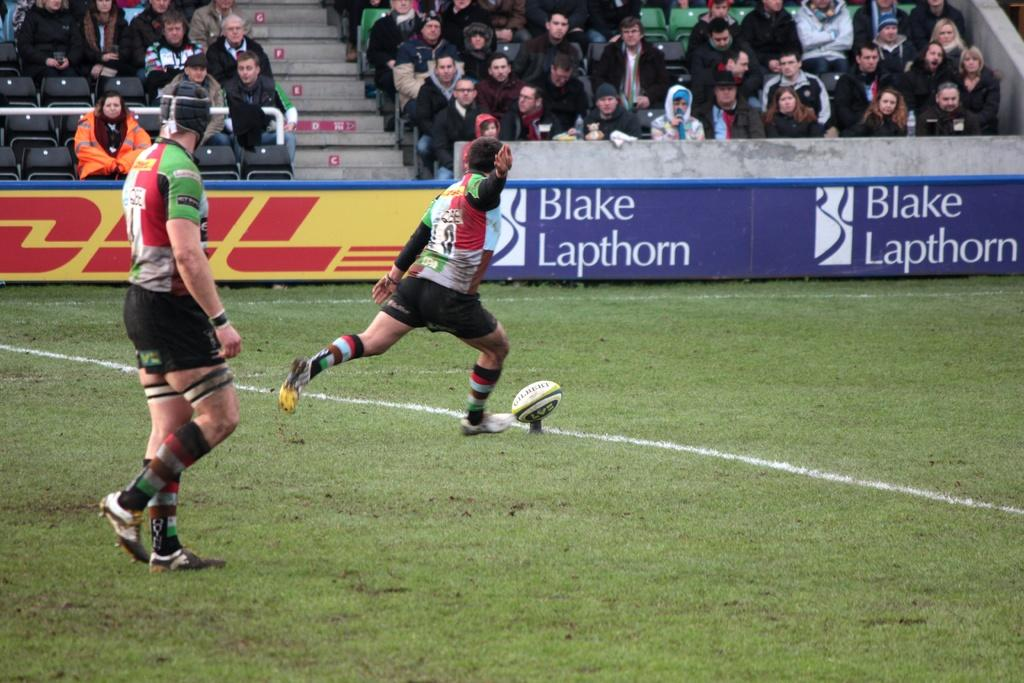<image>
Present a compact description of the photo's key features. A rugby players prepares for kick off on a field in front of signs advertising Blake Lapthorn and DHL. 